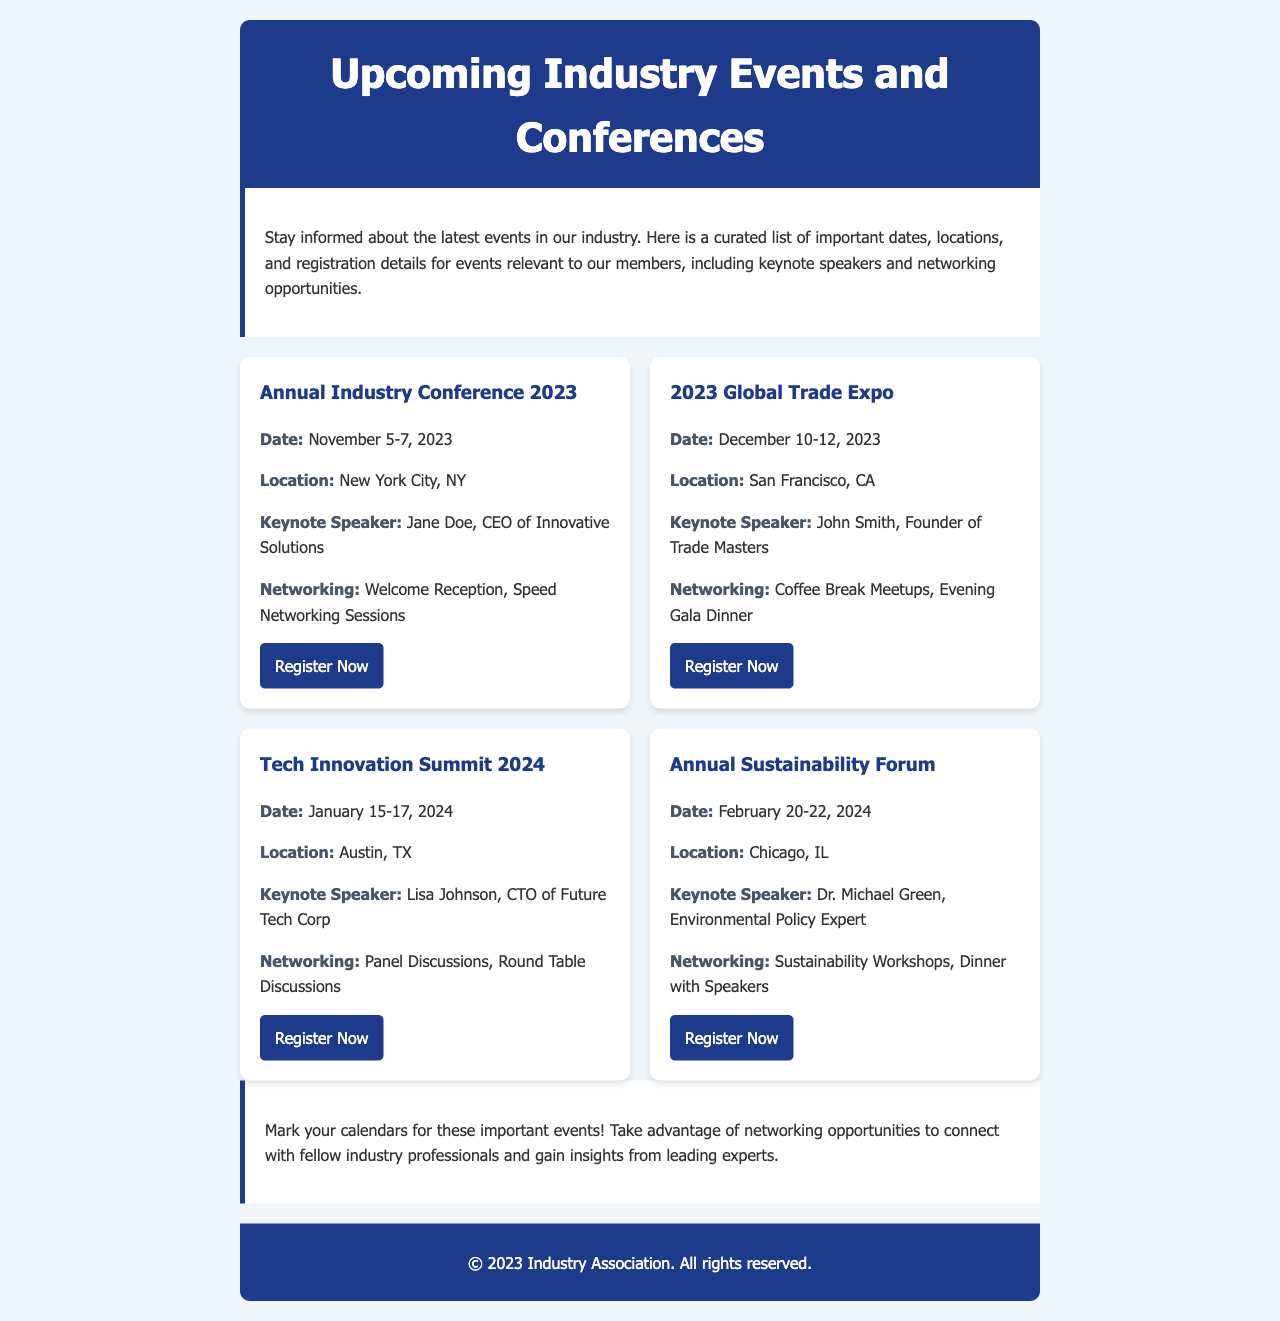What is the date of the Annual Industry Conference 2023? The date for the Annual Industry Conference 2023 is specified as November 5-7, 2023.
Answer: November 5-7, 2023 Where is the 2023 Global Trade Expo taking place? The location for the 2023 Global Trade Expo is mentioned as San Francisco, CA.
Answer: San Francisco, CA Who is the keynote speaker for the Tech Innovation Summit 2024? The document states that the keynote speaker for the Tech Innovation Summit 2024 is Lisa Johnson.
Answer: Lisa Johnson What networking opportunities are available at the Annual Sustainability Forum? The types of networking opportunities for the Annual Sustainability Forum include Sustainability Workshops and Dinner with Speakers.
Answer: Sustainability Workshops, Dinner with Speakers How many days does the Annual Industry Conference last? The Annual Industry Conference lasts for 3 days, as indicated by the date range provided.
Answer: 3 days What is the keynote speaker's title for the Annual Industry Conference 2023? The keynote speaker's title for the Annual Industry Conference 2023 is CEO of Innovative Solutions, as stated in the event details.
Answer: CEO of Innovative Solutions Which event occurs in January 2024? The event occurring in January 2024 is specifically listed as the Tech Innovation Summit 2024.
Answer: Tech Innovation Summit 2024 What type of event is the Annual Sustainability Forum? The Annual Sustainability Forum is categorized as a forum focused on sustainability topics and discussions.
Answer: Forum How can members register for the 2023 Global Trade Expo? Registration for the 2023 Global Trade Expo can be done through the provided link in the event section.
Answer: Through the provided link 